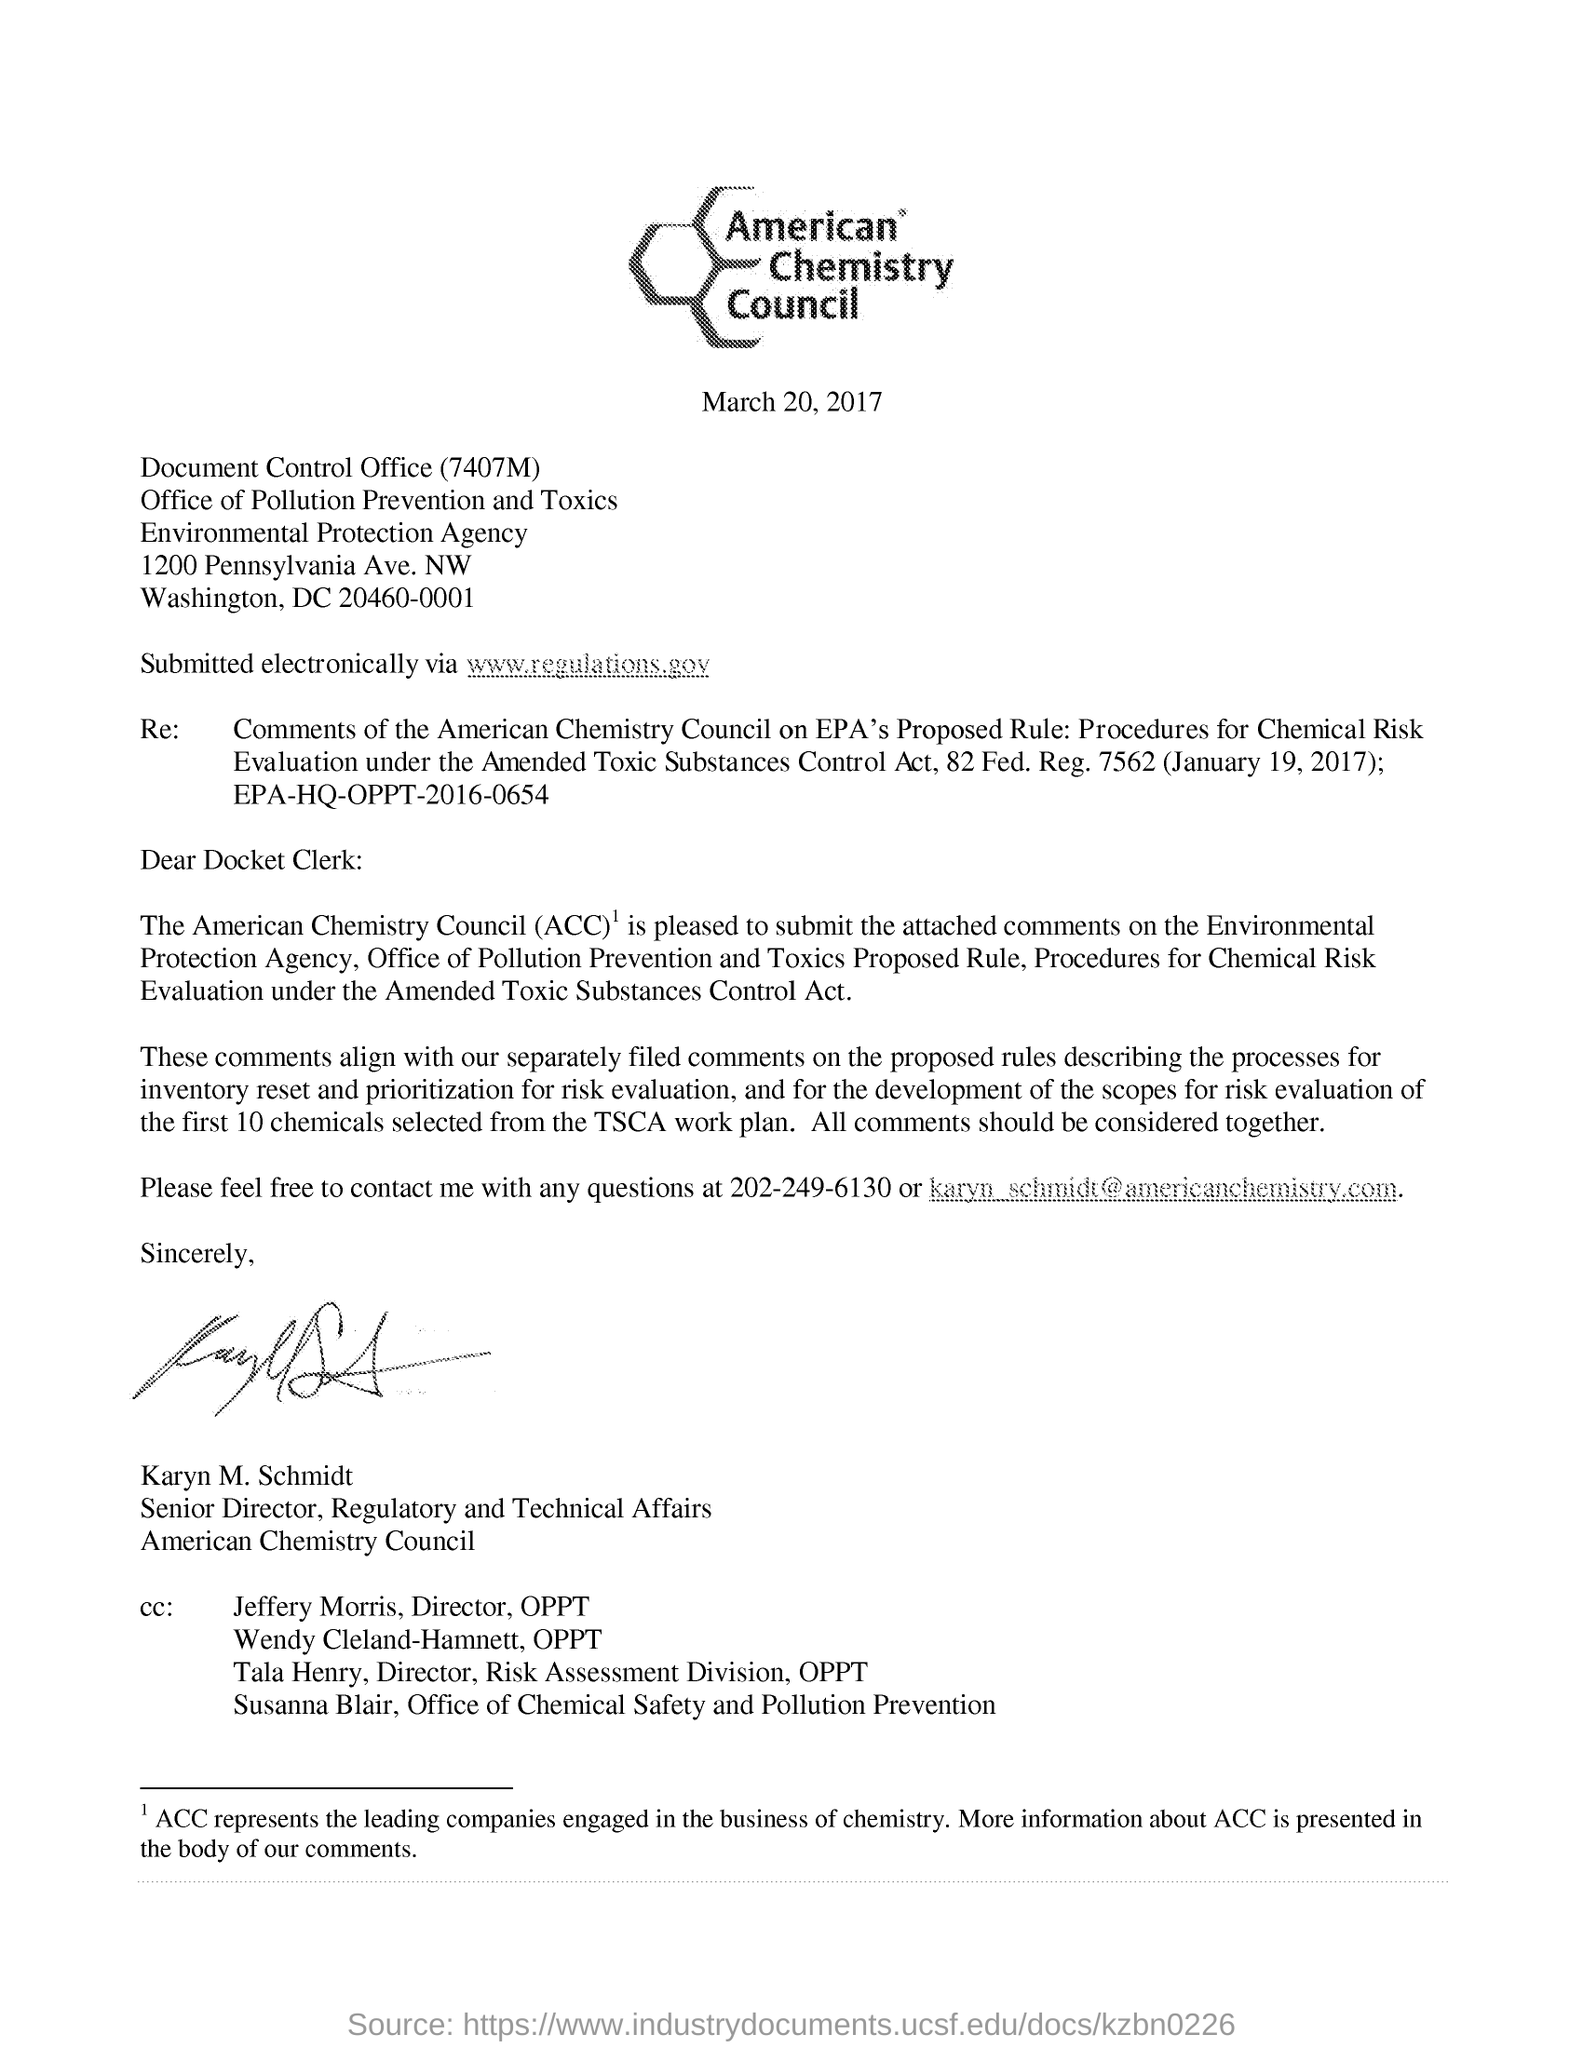How might these comments affect the regulation process? Comments from organizations like the American Chemistry Council can potentially influence the regulatory process by providing industry insights, technical data, and policy recommendations. The ACC represents companies in the chemical industry, and their feedback may highlight practical considerations, economic impacts, and scientific perspectives that the EPA may take into account when finalizing rules for chemical risk evaluation. Such comments can lead to modifications of proposed rules to balance safety with industry concerns, ensuring that regulations are both effective in protecting public health and the environment, and feasible for implementation by the industry. 